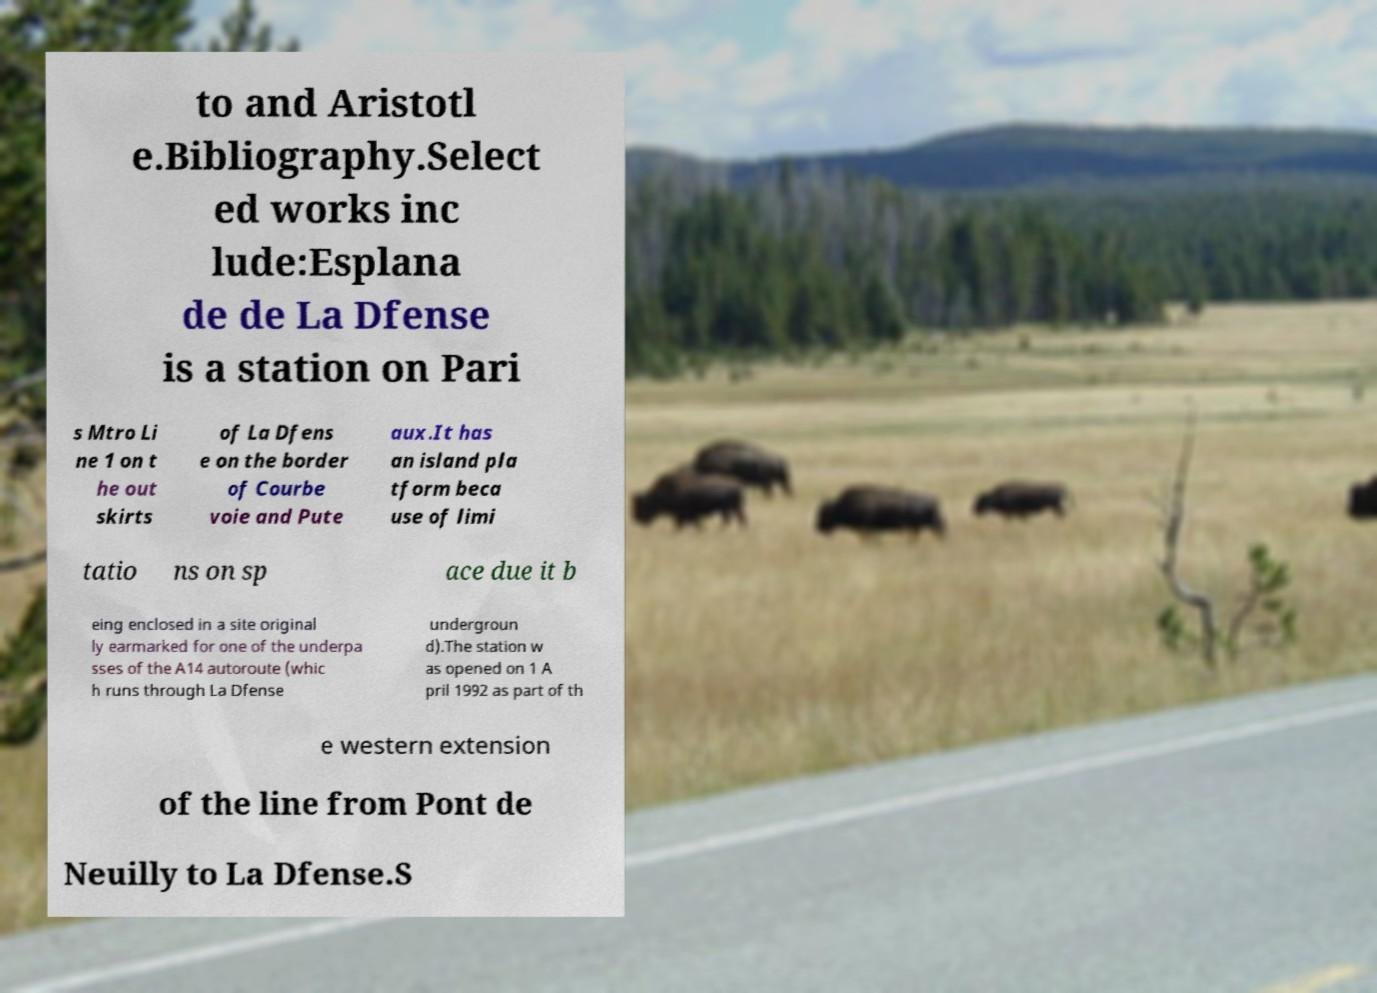Please read and relay the text visible in this image. What does it say? to and Aristotl e.Bibliography.Select ed works inc lude:Esplana de de La Dfense is a station on Pari s Mtro Li ne 1 on t he out skirts of La Dfens e on the border of Courbe voie and Pute aux.It has an island pla tform beca use of limi tatio ns on sp ace due it b eing enclosed in a site original ly earmarked for one of the underpa sses of the A14 autoroute (whic h runs through La Dfense undergroun d).The station w as opened on 1 A pril 1992 as part of th e western extension of the line from Pont de Neuilly to La Dfense.S 